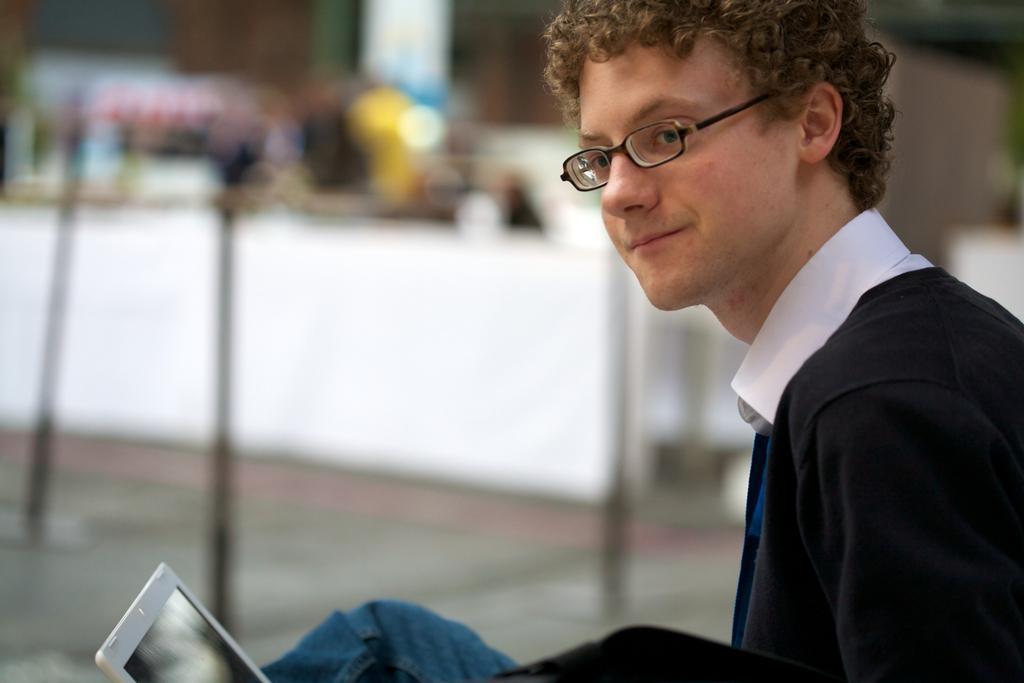How would you summarize this image in a sentence or two? In this image we can see a person with a specs. At the bottom we can see a laptop. In the background it is blur. 